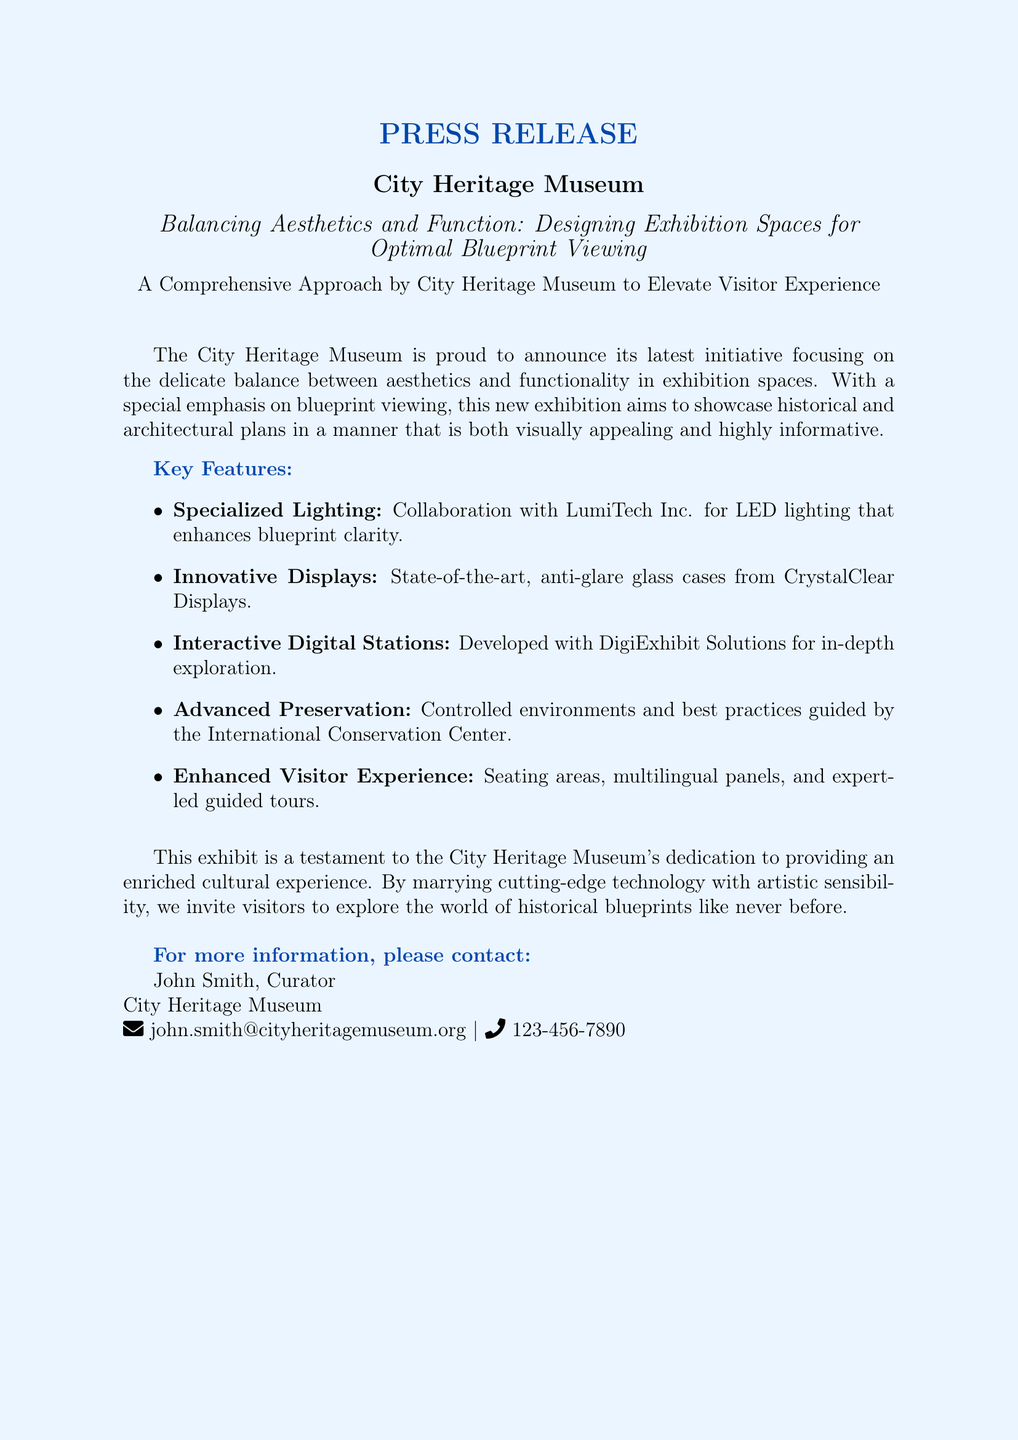What is the name of the museum? The name of the museum is stated at the beginning of the document, which is City Heritage Museum.
Answer: City Heritage Museum What is the title of the press release? The title is given prominently in the document, which is about designing exhibition spaces for blueprint viewing.
Answer: Balancing Aesthetics and Function: Designing Exhibition Spaces for Optimal Blueprint Viewing Who collaborated for specialized lighting? The collaboration for specialized lighting is mentioned in the key features section of the document as LumiTech Inc.
Answer: LumiTech Inc What type of cases are used for displays? The document specifies that state-of-the-art, anti-glare glass cases are utilized in the exhibition.
Answer: Anti-glare glass cases What is the purpose of the interactive digital stations? The purpose of the interactive digital stations is to provide in-depth exploration as described in the key features.
Answer: In-depth exploration How is visitor experience enhanced in the exhibit? The document outlines various enhancements like seating areas and multilingual panels that improve visitor experience.
Answer: Seating areas, multilingual panels, and expert-led guided tours Who is the contact person for more information? The document provides the name of the contact person for inquiries, which is mentioned as John Smith.
Answer: John Smith What company is responsible for advanced preservation? The document specifies that the guidance for advanced preservation comes from the International Conservation Center.
Answer: International Conservation Center 